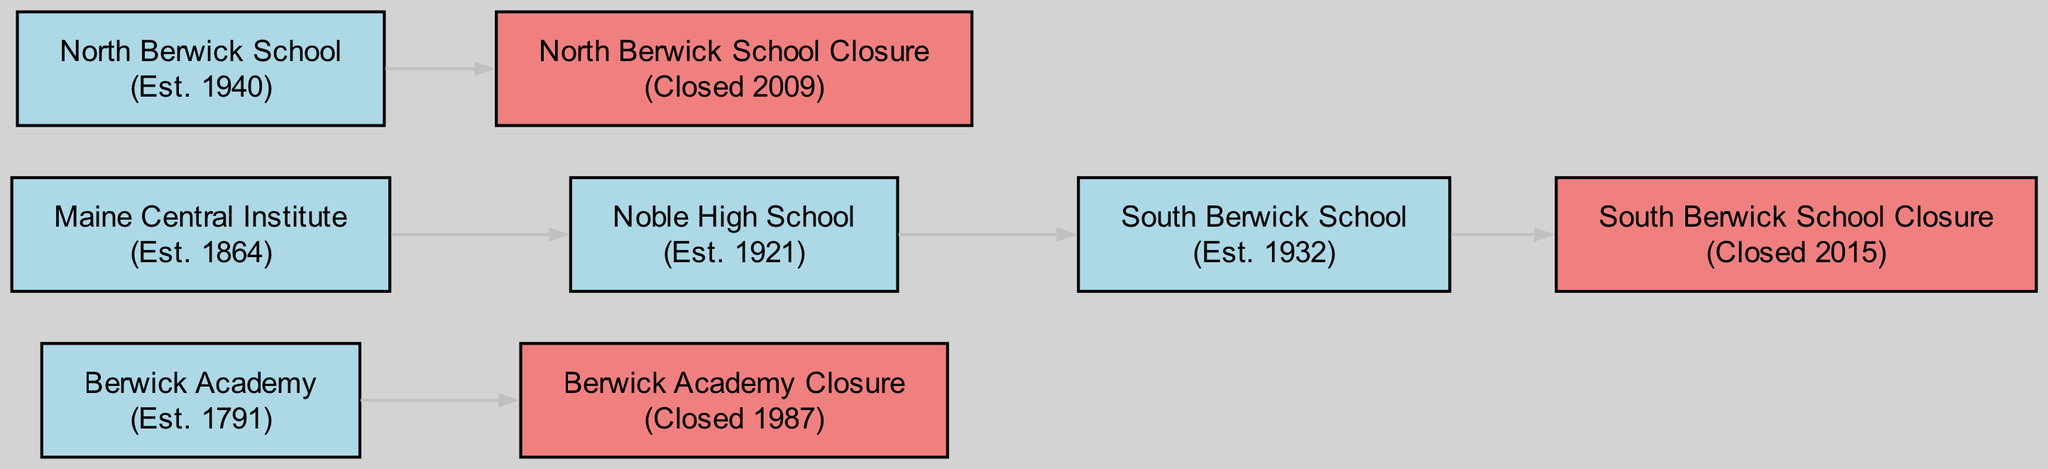What year was Berwick Academy established? The diagram indicates that Berwick Academy was established in 1791. This information is gathered from the node labeled "Berwick Academy" which lists the establishment year clearly.
Answer: 1791 When did North Berwick School close? According to the diagram, North Berwick School closed in 2009. The closure year is specified in the node labeled "North Berwick School Closure".
Answer: 2009 How many schools are represented in the diagram? By counting the nodes listed, it is clear there are a total of 8 schools represented (5 established and 3 closed). Counting each of the school-related nodes confirms this total.
Answer: 8 Which school was established most recently? The most recently established school is North Berwick School which opened in 1940. The establishment years of all schools are compared, and North Berwick School has the highest year.
Answer: North Berwick School What is the connection between Noble High School and South Berwick School? The directed edge from "Noble High School" to "South Berwick School" indicates that Noble High School feeds into or relates to South Berwick School, showing an established relationship.
Answer: Established connection How many schools closed after 2000? The diagram shows two schools that closed after 2000: North Berwick School (2009) and South Berwick School (2015). Both closure years are checked against the year 2000 to confirm they are after.
Answer: 2 Which school had the earliest establishment date? The diagram indicates that Berwick Academy had the earliest establishment date at 1791. By checking all the establishment years, Berwick Academy is identified as the first.
Answer: Berwick Academy What type of diagram is illustrated in this visual? The visual is a directed graph, which is characterized by its nodes and directed edges illustrating the relationships and flow from established schools to their closures.
Answer: Directed graph 